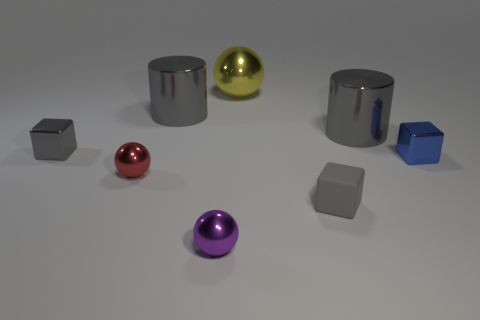Subtract all tiny blue shiny cubes. How many cubes are left? 2 Add 1 metallic cylinders. How many objects exist? 9 Subtract all purple spheres. How many spheres are left? 2 Subtract all balls. How many objects are left? 5 Subtract all purple cylinders. How many gray blocks are left? 2 Subtract all tiny red metal spheres. Subtract all blue objects. How many objects are left? 6 Add 8 tiny blue metal blocks. How many tiny blue metal blocks are left? 9 Add 8 large blue balls. How many large blue balls exist? 8 Subtract 0 purple cylinders. How many objects are left? 8 Subtract 3 spheres. How many spheres are left? 0 